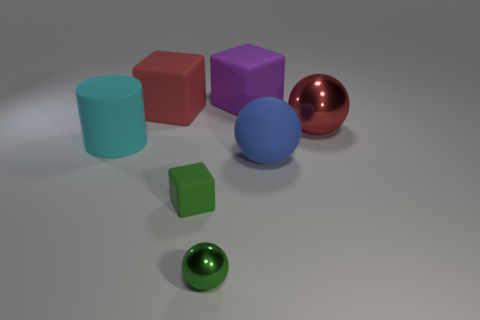There is a red thing that is to the right of the purple thing; is it the same shape as the purple matte object?
Ensure brevity in your answer.  No. What is the shape of the rubber thing in front of the large sphere to the left of the metal object that is behind the cyan rubber object?
Offer a very short reply. Cube. How big is the cylinder?
Offer a very short reply. Large. There is a sphere that is made of the same material as the cyan cylinder; what is its color?
Your response must be concise. Blue. What number of small green objects have the same material as the tiny ball?
Your answer should be very brief. 0. Is the color of the tiny metal sphere the same as the matte cube that is in front of the cyan rubber cylinder?
Keep it short and to the point. Yes. There is a metal ball that is to the left of the large block on the right side of the small cube; what color is it?
Offer a very short reply. Green. There is a sphere that is the same size as the green matte cube; what is its color?
Give a very brief answer. Green. Is there a big cyan matte object that has the same shape as the green matte object?
Offer a very short reply. No. There is a cyan matte thing; what shape is it?
Provide a succinct answer. Cylinder. 